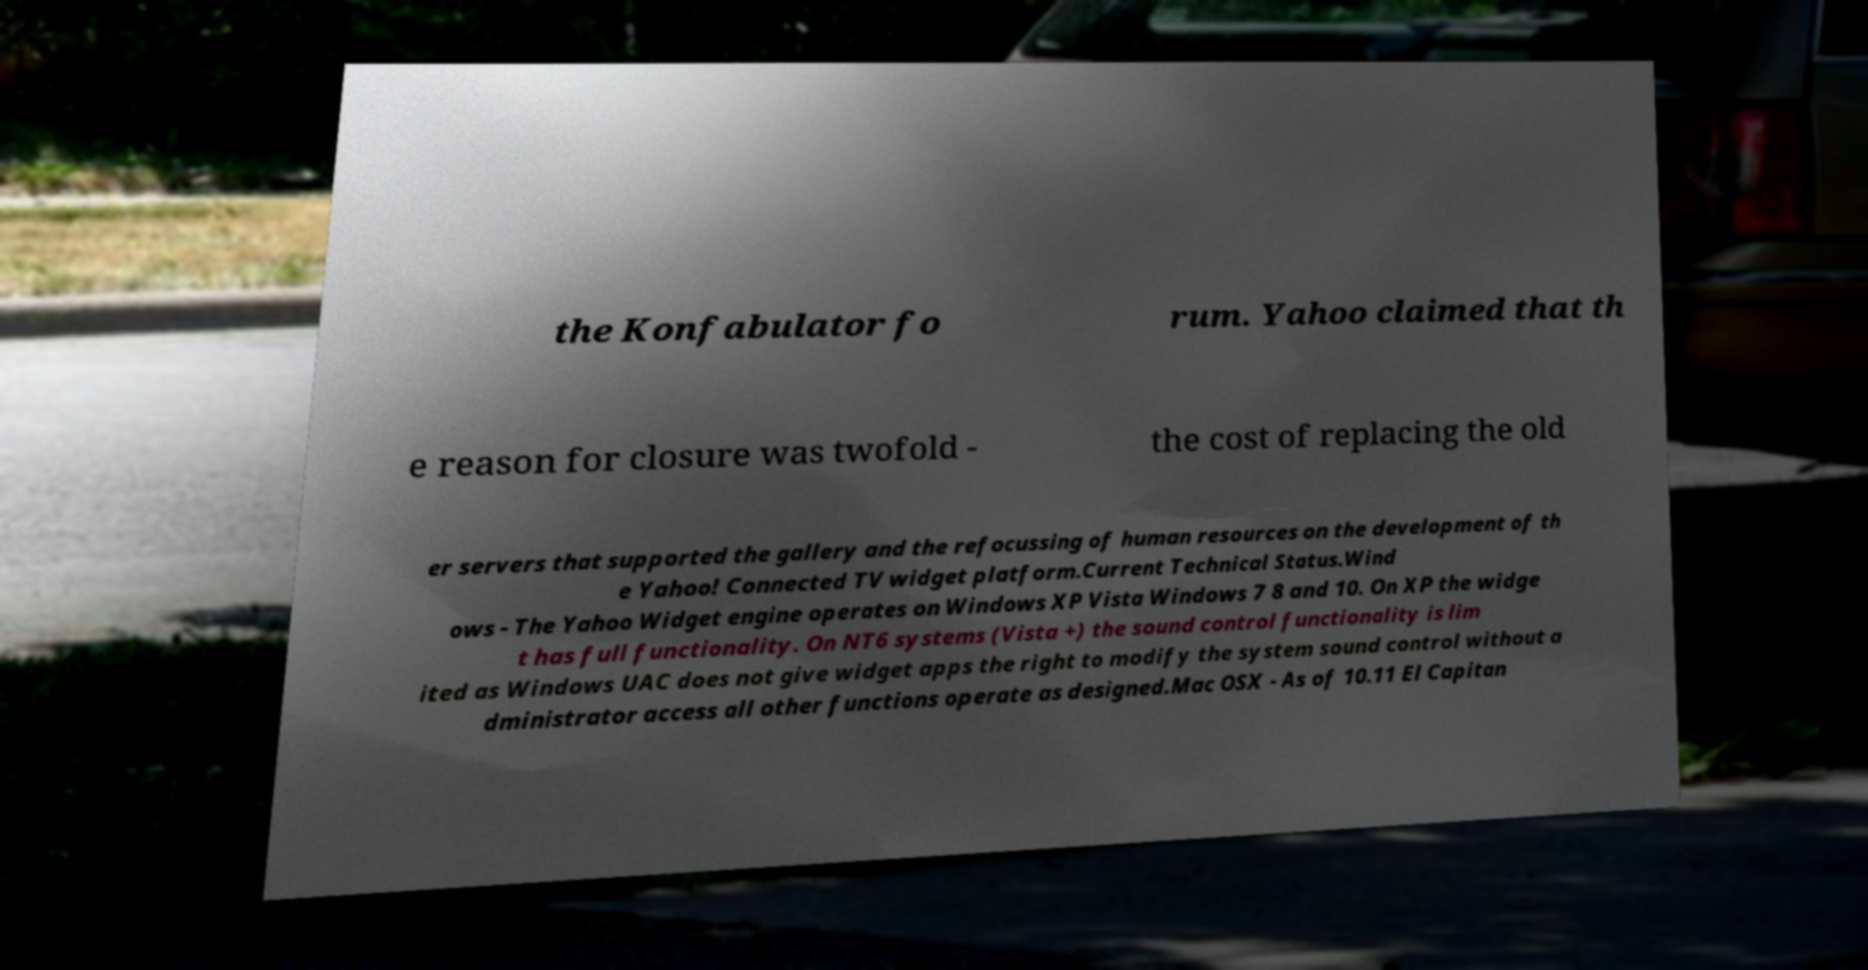What messages or text are displayed in this image? I need them in a readable, typed format. the Konfabulator fo rum. Yahoo claimed that th e reason for closure was twofold - the cost of replacing the old er servers that supported the gallery and the refocussing of human resources on the development of th e Yahoo! Connected TV widget platform.Current Technical Status.Wind ows - The Yahoo Widget engine operates on Windows XP Vista Windows 7 8 and 10. On XP the widge t has full functionality. On NT6 systems (Vista +) the sound control functionality is lim ited as Windows UAC does not give widget apps the right to modify the system sound control without a dministrator access all other functions operate as designed.Mac OSX - As of 10.11 El Capitan 